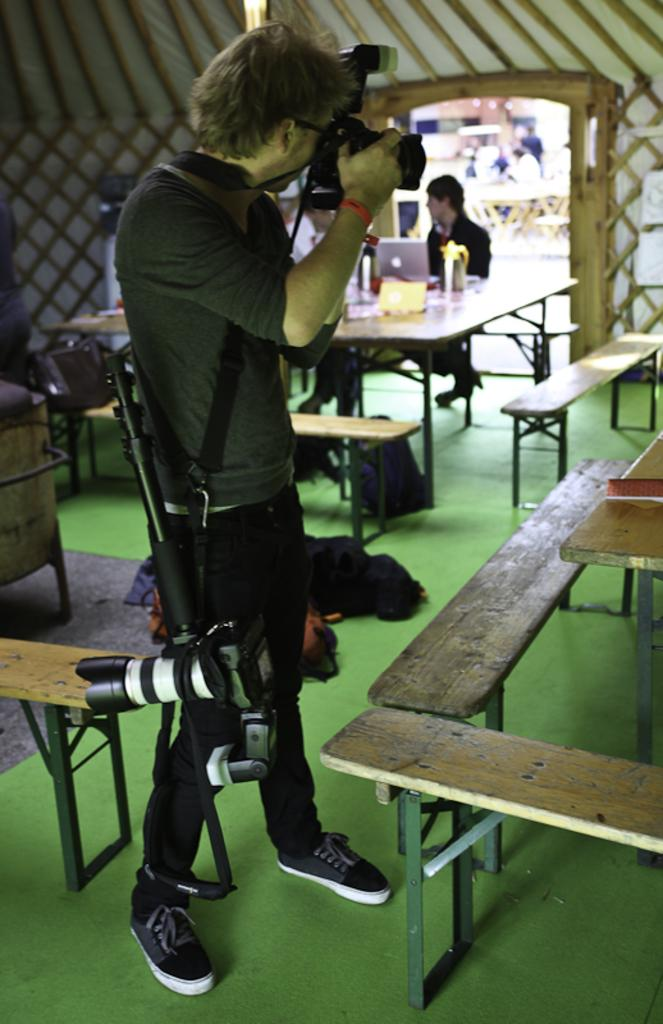What can be seen in the image? There is a person in the image. What is the person wearing? The person is wearing a T-shirt. What is the person holding in their hands? The person is holding a camera in their hands. How is the person carrying the camera? The person is carrying a camera. Can you describe the background of the image? There is a person sitting on a bench in the background of the image. What type of approval does the person need to obtain before taking a picture of the person sitting on the bench? There is no indication in the image that the person needs any approval to take a picture of the person sitting on the bench. 